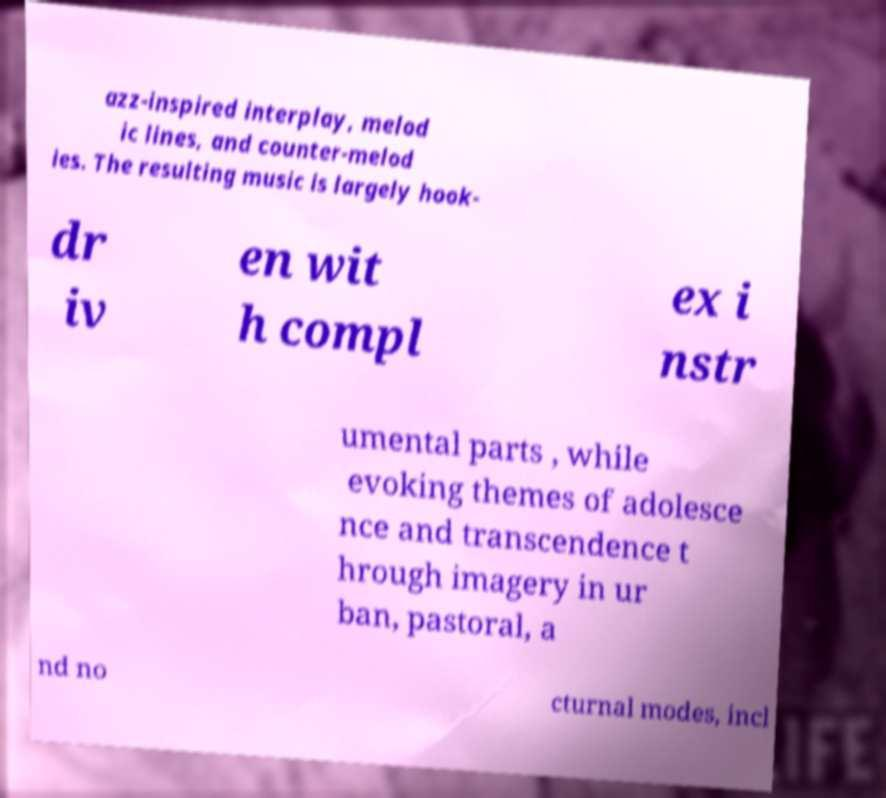Can you accurately transcribe the text from the provided image for me? azz-inspired interplay, melod ic lines, and counter-melod ies. The resulting music is largely hook- dr iv en wit h compl ex i nstr umental parts , while evoking themes of adolesce nce and transcendence t hrough imagery in ur ban, pastoral, a nd no cturnal modes, incl 